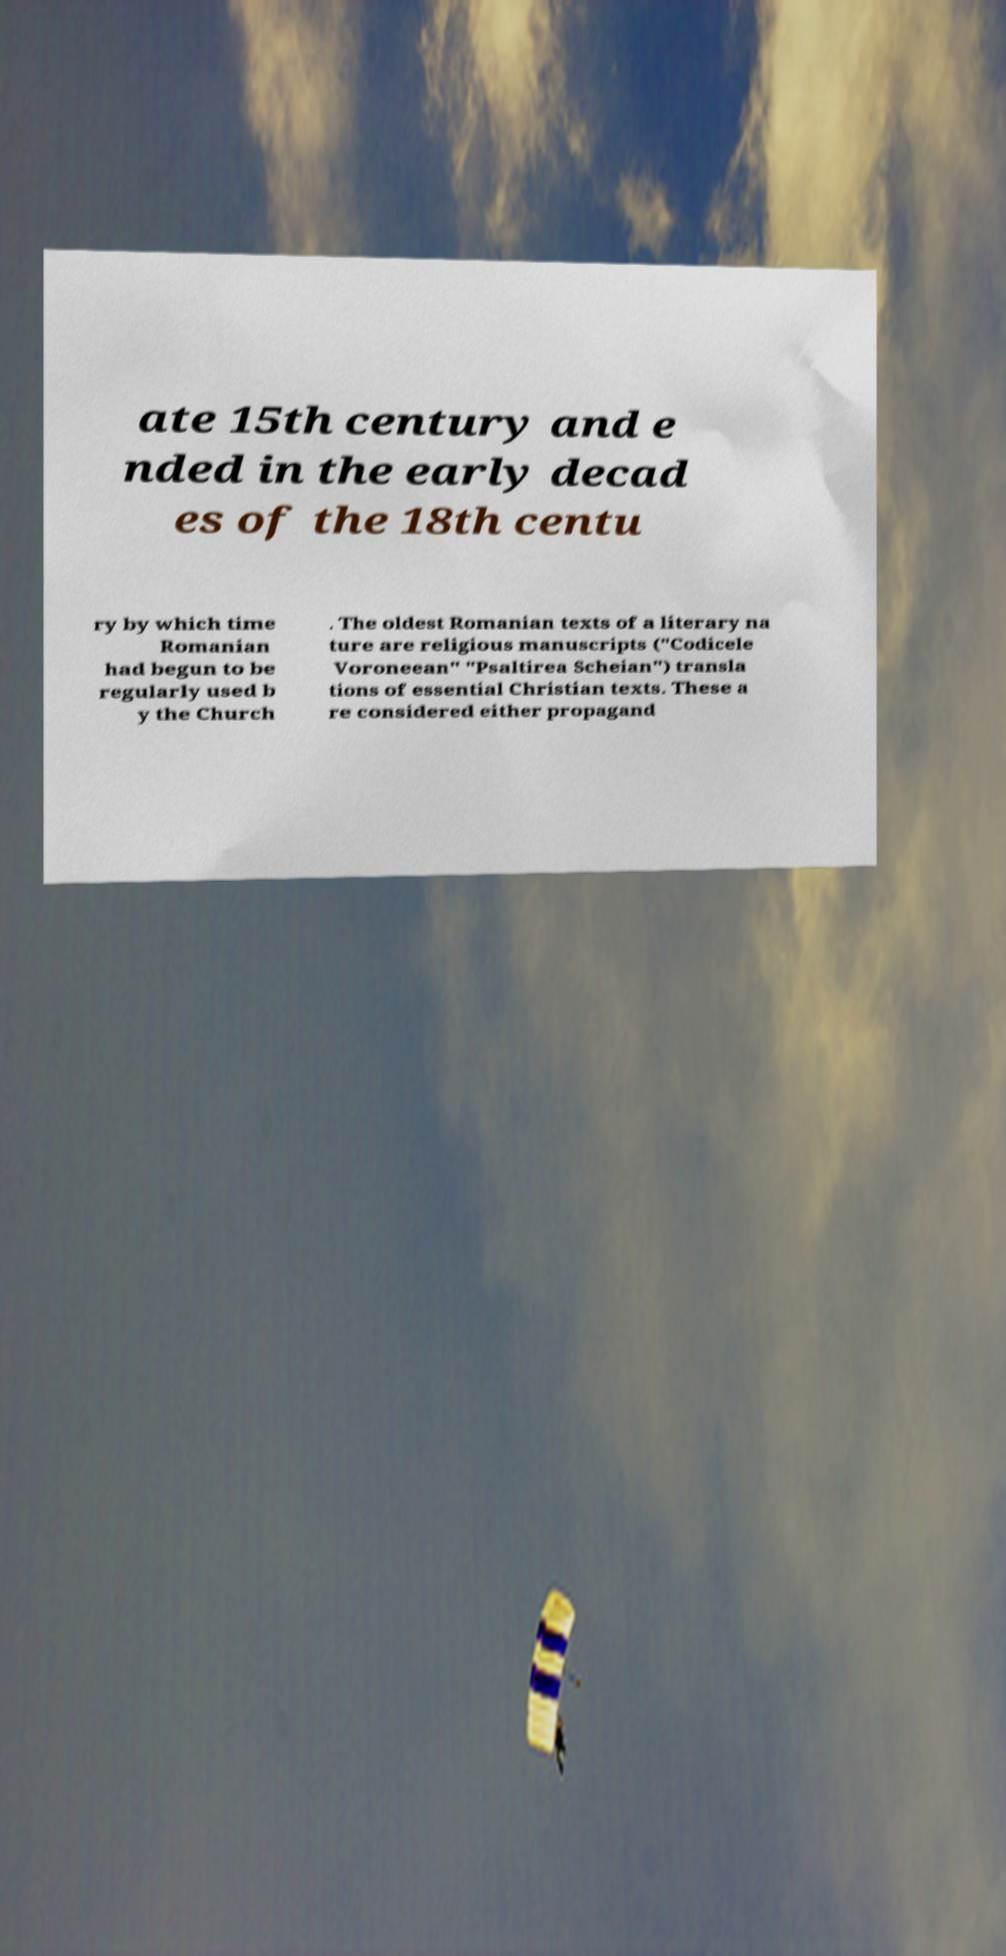Could you extract and type out the text from this image? ate 15th century and e nded in the early decad es of the 18th centu ry by which time Romanian had begun to be regularly used b y the Church . The oldest Romanian texts of a literary na ture are religious manuscripts ("Codicele Voroneean" "Psaltirea Scheian") transla tions of essential Christian texts. These a re considered either propagand 